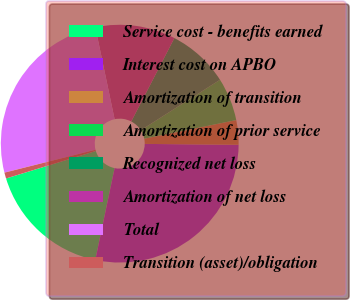<chart> <loc_0><loc_0><loc_500><loc_500><pie_chart><fcel>Service cost - benefits earned<fcel>Interest cost on APBO<fcel>Amortization of transition<fcel>Amortization of prior service<fcel>Recognized net loss<fcel>Amortization of net loss<fcel>Total<fcel>Transition (asset)/obligation<nl><fcel>16.97%<fcel>28.15%<fcel>3.33%<fcel>5.85%<fcel>8.37%<fcel>10.89%<fcel>25.63%<fcel>0.81%<nl></chart> 